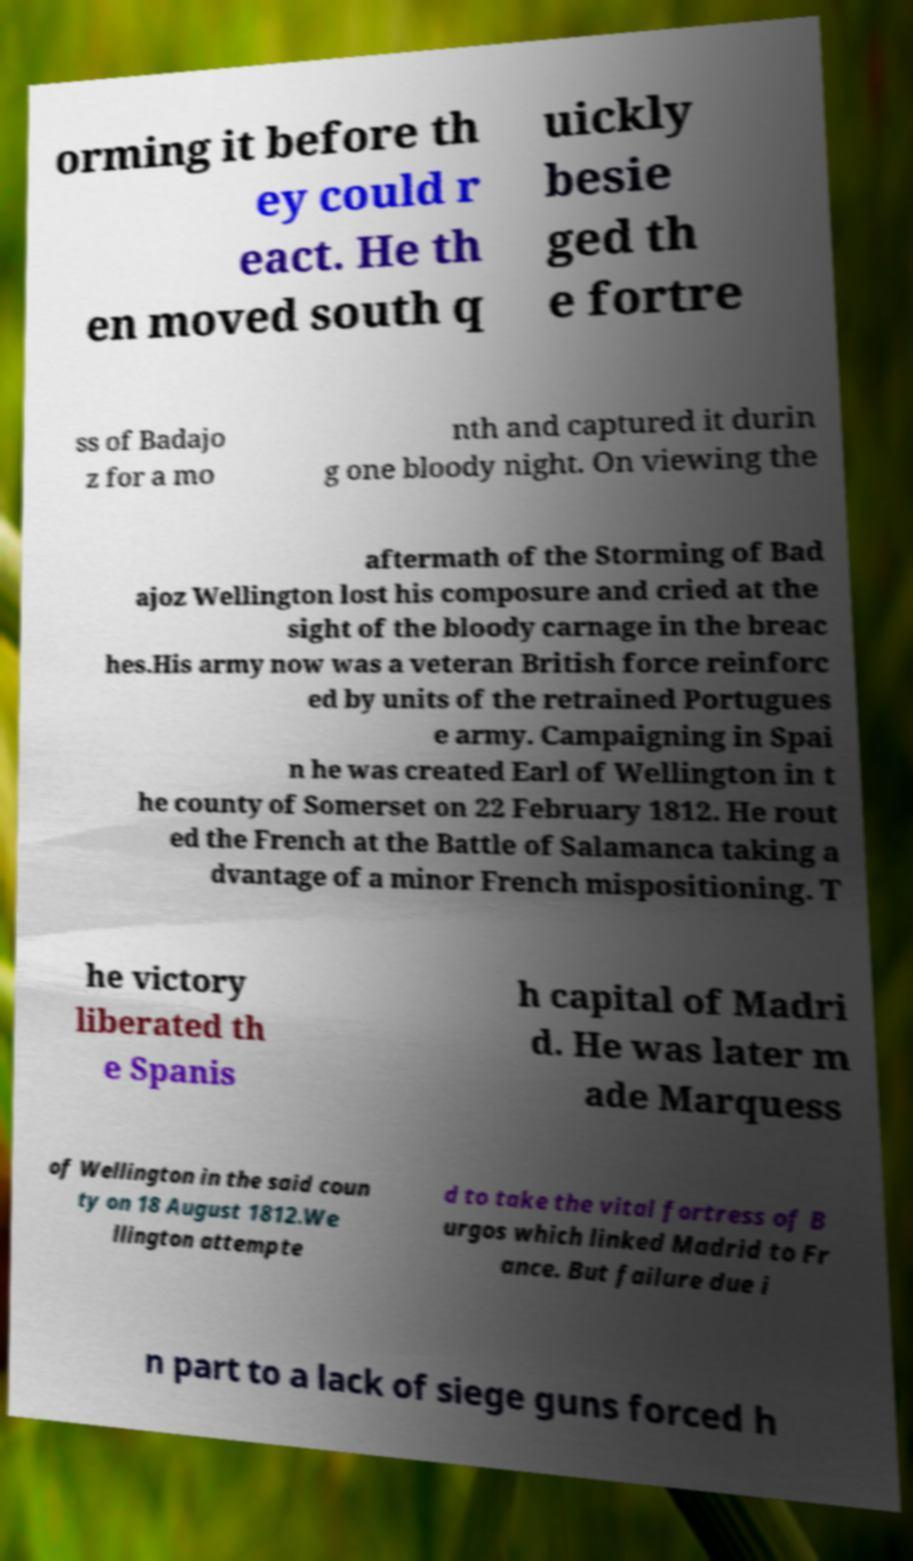There's text embedded in this image that I need extracted. Can you transcribe it verbatim? orming it before th ey could r eact. He th en moved south q uickly besie ged th e fortre ss of Badajo z for a mo nth and captured it durin g one bloody night. On viewing the aftermath of the Storming of Bad ajoz Wellington lost his composure and cried at the sight of the bloody carnage in the breac hes.His army now was a veteran British force reinforc ed by units of the retrained Portugues e army. Campaigning in Spai n he was created Earl of Wellington in t he county of Somerset on 22 February 1812. He rout ed the French at the Battle of Salamanca taking a dvantage of a minor French mispositioning. T he victory liberated th e Spanis h capital of Madri d. He was later m ade Marquess of Wellington in the said coun ty on 18 August 1812.We llington attempte d to take the vital fortress of B urgos which linked Madrid to Fr ance. But failure due i n part to a lack of siege guns forced h 